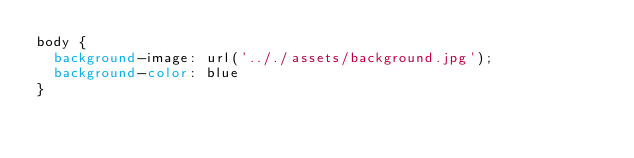<code> <loc_0><loc_0><loc_500><loc_500><_CSS_>body {
  background-image: url('.././assets/background.jpg');
  background-color: blue
}
</code> 